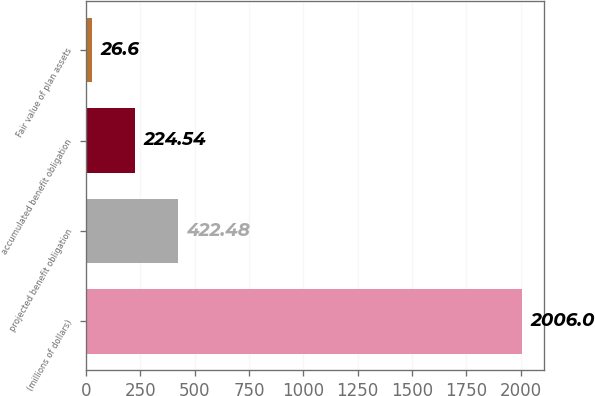Convert chart to OTSL. <chart><loc_0><loc_0><loc_500><loc_500><bar_chart><fcel>(millions of dollars)<fcel>projected benefit obligation<fcel>accumulated benefit obligation<fcel>Fair value of plan assets<nl><fcel>2006<fcel>422.48<fcel>224.54<fcel>26.6<nl></chart> 